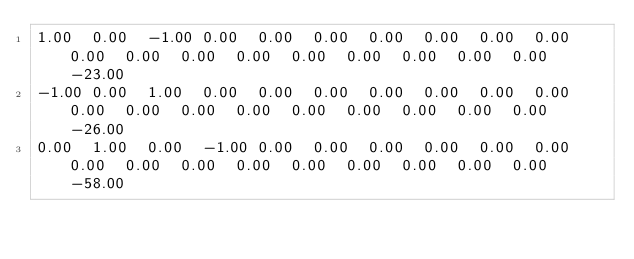<code> <loc_0><loc_0><loc_500><loc_500><_Matlab_>1.00	0.00	-1.00	0.00	0.00	0.00	0.00	0.00	0.00	0.00	0.00	0.00	0.00	0.00	0.00	0.00	0.00	0.00	0.00	-23.00
-1.00	0.00	1.00	0.00	0.00	0.00	0.00	0.00	0.00	0.00	0.00	0.00	0.00	0.00	0.00	0.00	0.00	0.00	0.00	-26.00
0.00	1.00	0.00	-1.00	0.00	0.00	0.00	0.00	0.00	0.00	0.00	0.00	0.00	0.00	0.00	0.00	0.00	0.00	0.00	-58.00</code> 